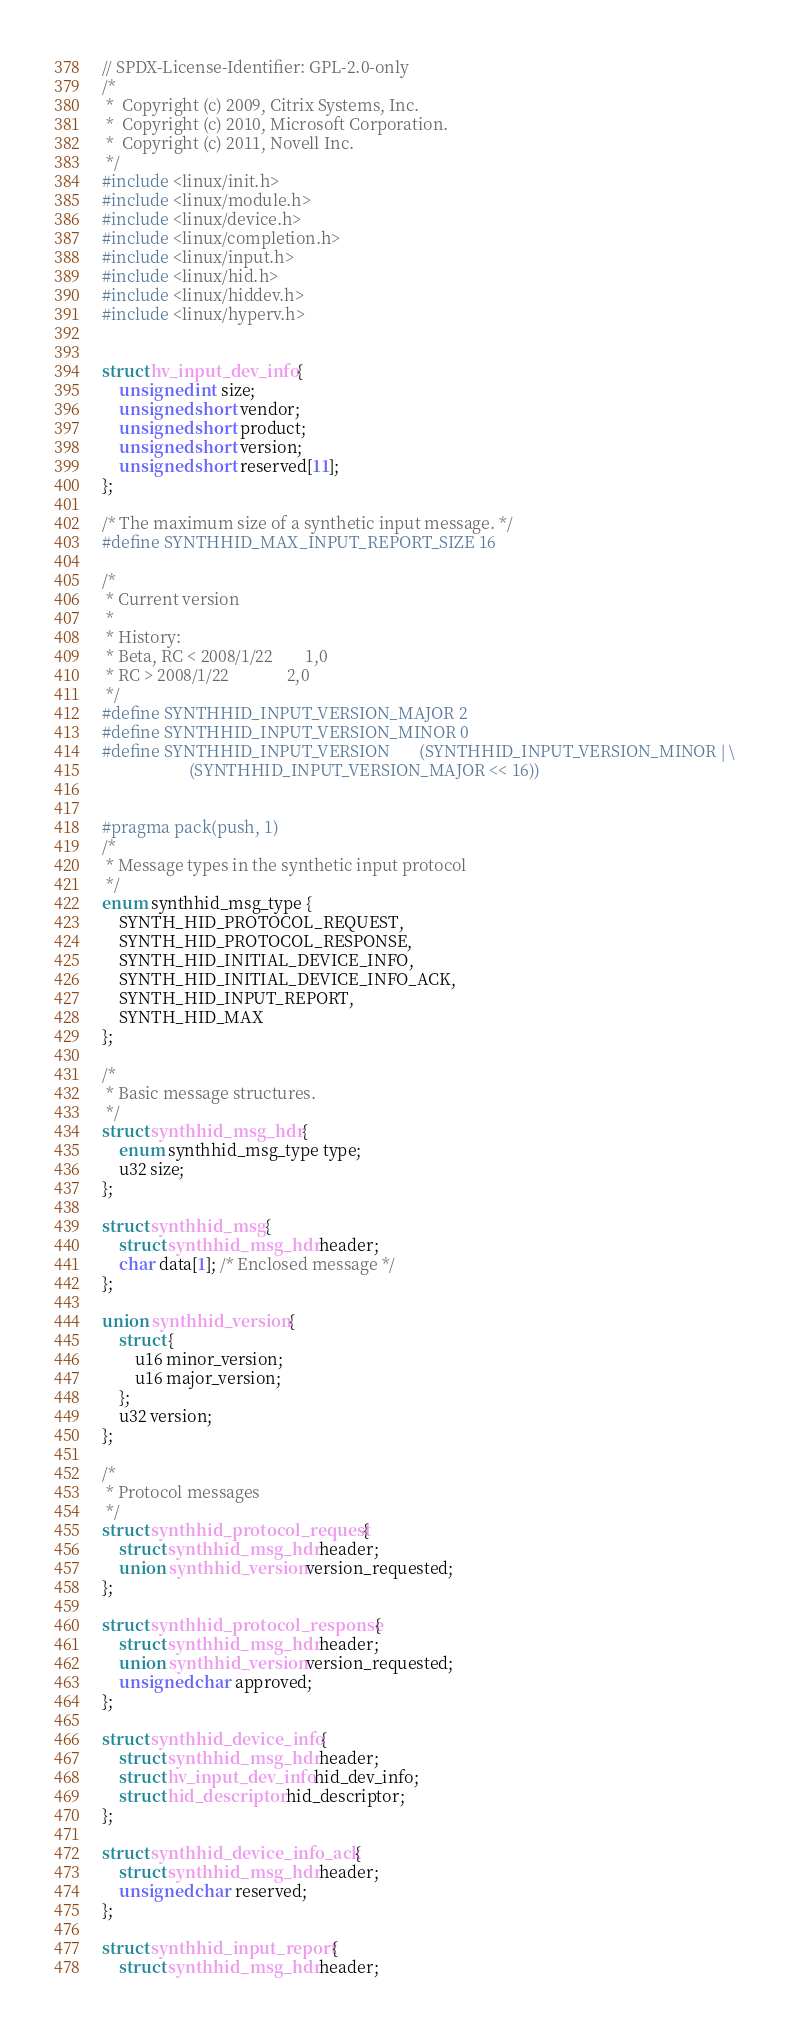<code> <loc_0><loc_0><loc_500><loc_500><_C_>// SPDX-License-Identifier: GPL-2.0-only
/*
 *  Copyright (c) 2009, Citrix Systems, Inc.
 *  Copyright (c) 2010, Microsoft Corporation.
 *  Copyright (c) 2011, Novell Inc.
 */
#include <linux/init.h>
#include <linux/module.h>
#include <linux/device.h>
#include <linux/completion.h>
#include <linux/input.h>
#include <linux/hid.h>
#include <linux/hiddev.h>
#include <linux/hyperv.h>


struct hv_input_dev_info {
	unsigned int size;
	unsigned short vendor;
	unsigned short product;
	unsigned short version;
	unsigned short reserved[11];
};

/* The maximum size of a synthetic input message. */
#define SYNTHHID_MAX_INPUT_REPORT_SIZE 16

/*
 * Current version
 *
 * History:
 * Beta, RC < 2008/1/22        1,0
 * RC > 2008/1/22              2,0
 */
#define SYNTHHID_INPUT_VERSION_MAJOR	2
#define SYNTHHID_INPUT_VERSION_MINOR	0
#define SYNTHHID_INPUT_VERSION		(SYNTHHID_INPUT_VERSION_MINOR | \
					 (SYNTHHID_INPUT_VERSION_MAJOR << 16))


#pragma pack(push, 1)
/*
 * Message types in the synthetic input protocol
 */
enum synthhid_msg_type {
	SYNTH_HID_PROTOCOL_REQUEST,
	SYNTH_HID_PROTOCOL_RESPONSE,
	SYNTH_HID_INITIAL_DEVICE_INFO,
	SYNTH_HID_INITIAL_DEVICE_INFO_ACK,
	SYNTH_HID_INPUT_REPORT,
	SYNTH_HID_MAX
};

/*
 * Basic message structures.
 */
struct synthhid_msg_hdr {
	enum synthhid_msg_type type;
	u32 size;
};

struct synthhid_msg {
	struct synthhid_msg_hdr header;
	char data[1]; /* Enclosed message */
};

union synthhid_version {
	struct {
		u16 minor_version;
		u16 major_version;
	};
	u32 version;
};

/*
 * Protocol messages
 */
struct synthhid_protocol_request {
	struct synthhid_msg_hdr header;
	union synthhid_version version_requested;
};

struct synthhid_protocol_response {
	struct synthhid_msg_hdr header;
	union synthhid_version version_requested;
	unsigned char approved;
};

struct synthhid_device_info {
	struct synthhid_msg_hdr header;
	struct hv_input_dev_info hid_dev_info;
	struct hid_descriptor hid_descriptor;
};

struct synthhid_device_info_ack {
	struct synthhid_msg_hdr header;
	unsigned char reserved;
};

struct synthhid_input_report {
	struct synthhid_msg_hdr header;</code> 